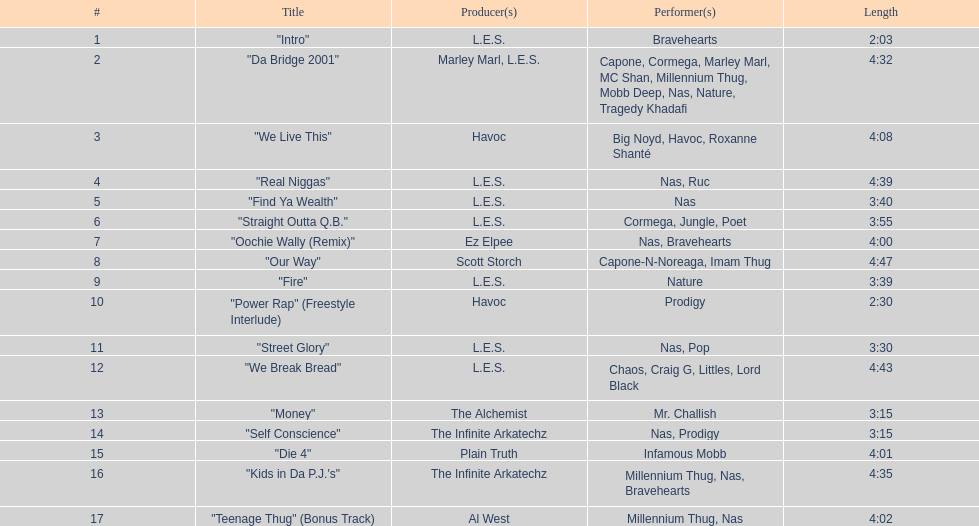What is the initial track on the album created by havoc? "We Live This". 